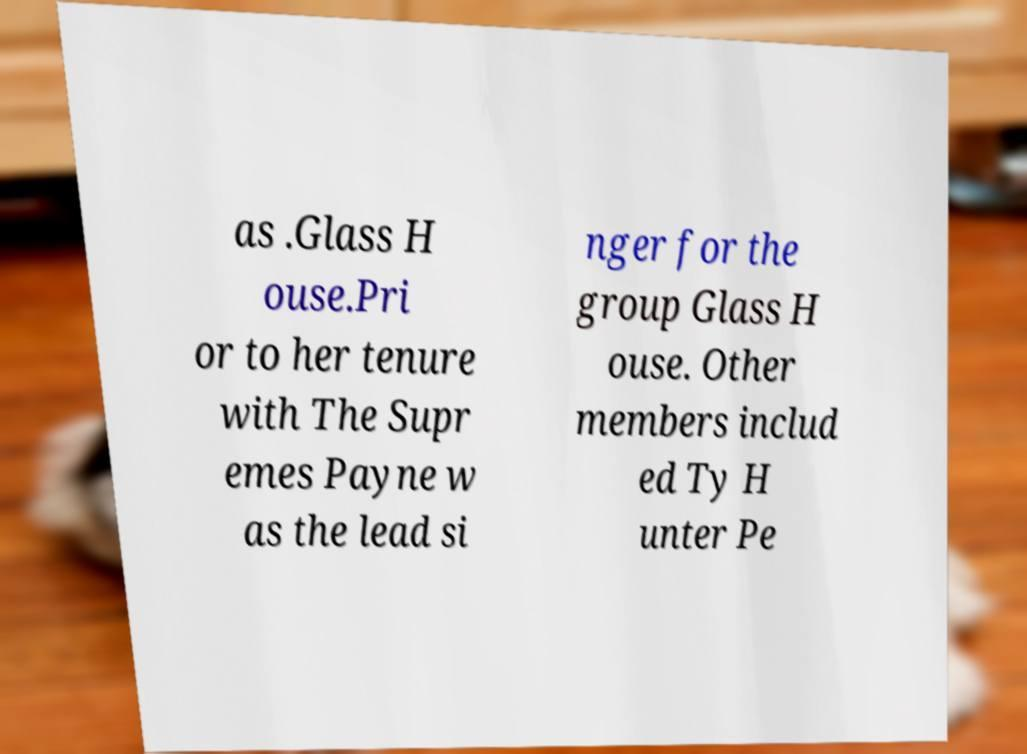There's text embedded in this image that I need extracted. Can you transcribe it verbatim? as .Glass H ouse.Pri or to her tenure with The Supr emes Payne w as the lead si nger for the group Glass H ouse. Other members includ ed Ty H unter Pe 